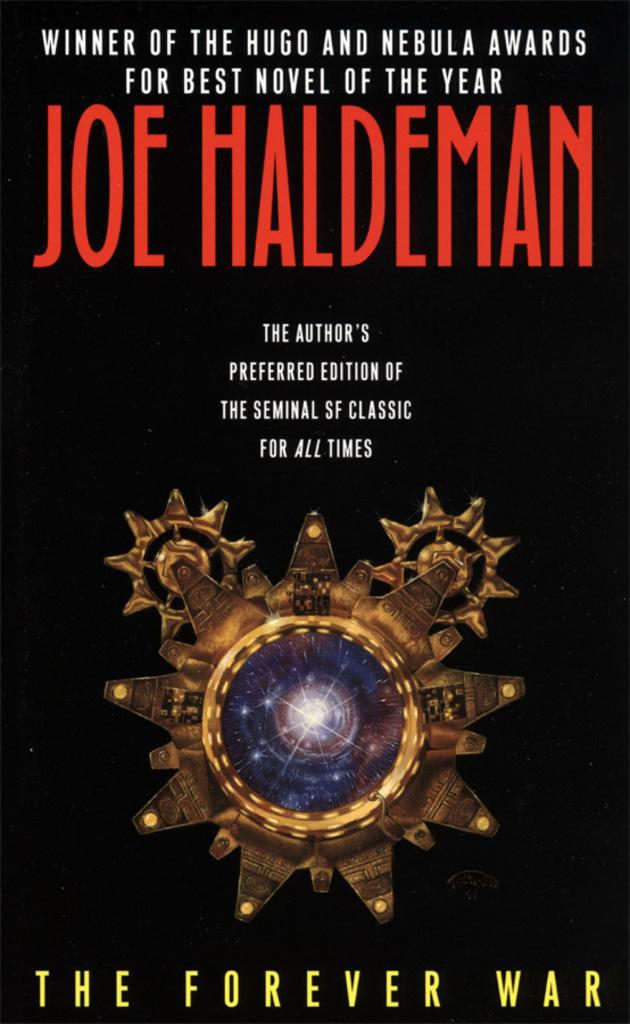<image>
Give a short and clear explanation of the subsequent image. A book has a black cover and is titled The Forever War. 